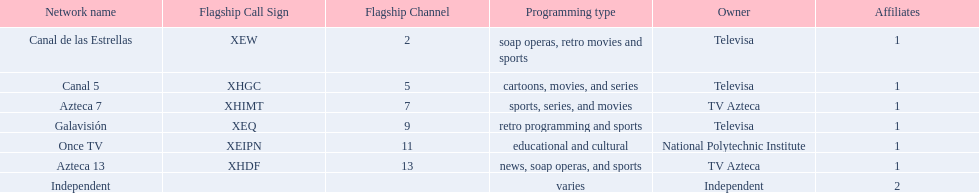What station shows cartoons? Canal 5. What station shows soap operas? Canal de las Estrellas. What station shows sports? Azteca 7. 